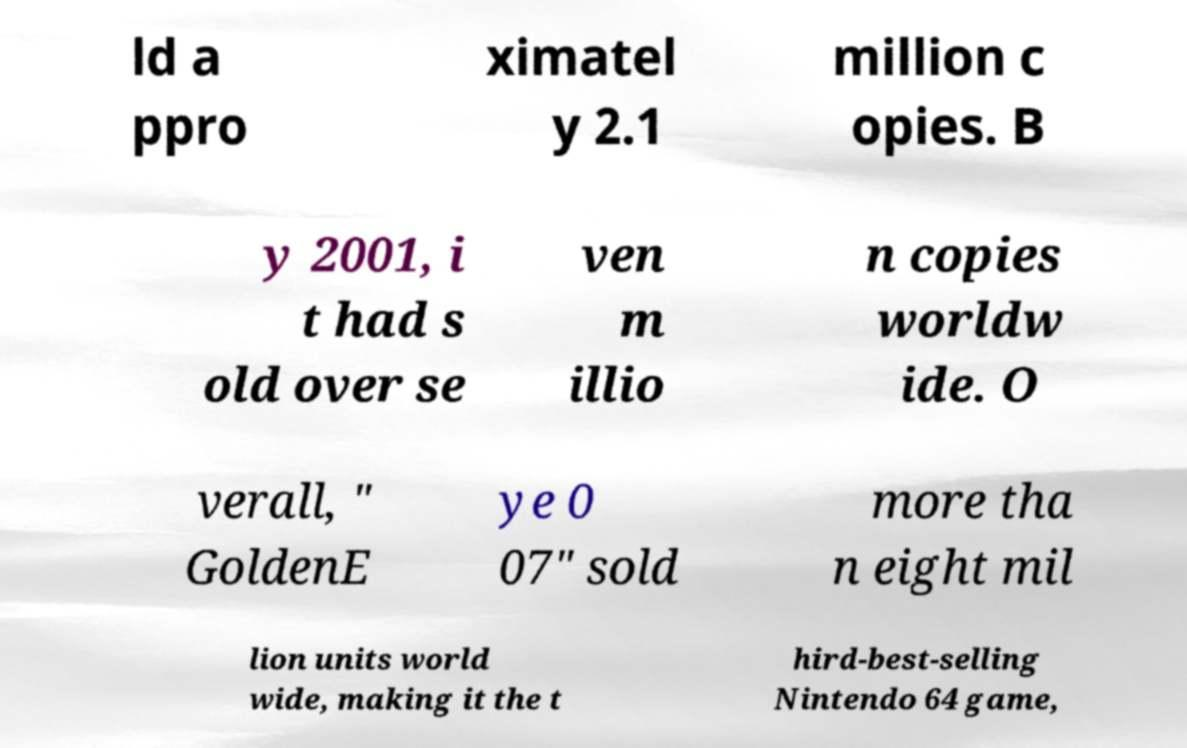Please read and relay the text visible in this image. What does it say? ld a ppro ximatel y 2.1 million c opies. B y 2001, i t had s old over se ven m illio n copies worldw ide. O verall, " GoldenE ye 0 07" sold more tha n eight mil lion units world wide, making it the t hird-best-selling Nintendo 64 game, 